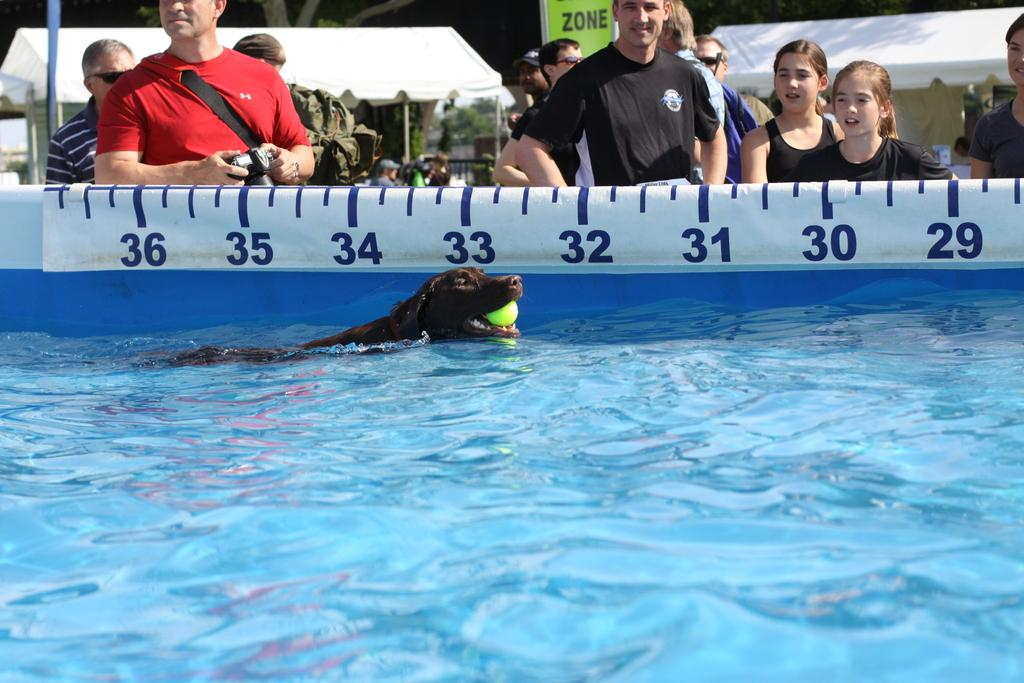What is the main subject in the foreground of the picture? There is a dog in the foreground of the picture. What is the dog doing in the picture? The dog is holding a ball in its mouth. Where is the dog located in the picture? The dog is in a swimming pool. What can be seen in the background of the picture? There are persons watching the dog and tents in the background. What is the opinion of the fan about the dog's performance in the image? There is no fan mentioned in the image, and therefore no opinion can be attributed to a fan. 